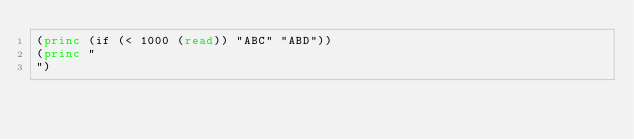<code> <loc_0><loc_0><loc_500><loc_500><_Lisp_>(princ (if (< 1000 (read)) "ABC" "ABD"))
(princ "
")</code> 